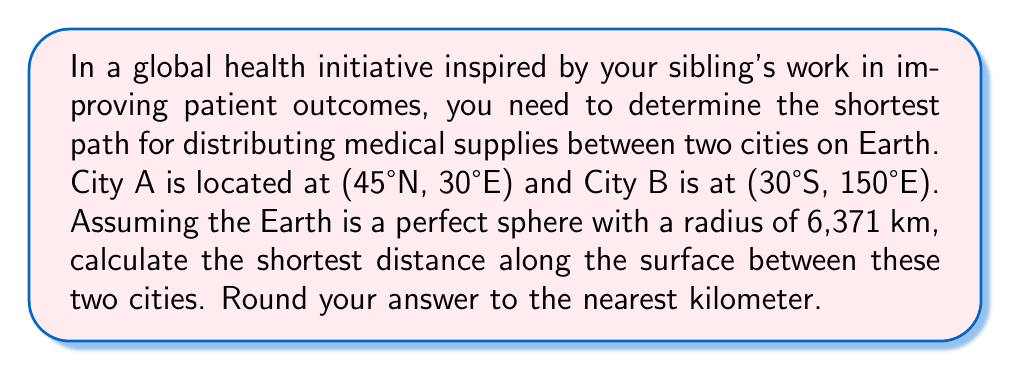Can you solve this math problem? To solve this problem, we need to use the great circle distance formula, which gives the shortest path between two points on a spherical surface. This is crucial for optimal healthcare resource allocation on a global scale.

Step 1: Convert the given coordinates to radians.
City A: $\phi_1 = 45° \cdot \frac{\pi}{180} = 0.7854$ rad, $\lambda_1 = 30° \cdot \frac{\pi}{180} = 0.5236$ rad
City B: $\phi_2 = -30° \cdot \frac{\pi}{180} = -0.5236$ rad, $\lambda_2 = 150° \cdot \frac{\pi}{180} = 2.6180$ rad

Step 2: Calculate the central angle $\Delta\sigma$ using the great circle distance formula:
$$\Delta\sigma = \arccos(\sin\phi_1 \sin\phi_2 + \cos\phi_1 \cos\phi_2 \cos(\lambda_2 - \lambda_1))$$

Step 3: Substitute the values:
$$\Delta\sigma = \arccos(\sin(0.7854) \sin(-0.5236) + \cos(0.7854) \cos(-0.5236) \cos(2.6180 - 0.5236))$$

Step 4: Calculate the result:
$$\Delta\sigma = 1.9635 \text{ radians}$$

Step 5: Calculate the distance $d$ along the Earth's surface:
$$d = R \cdot \Delta\sigma$$
where $R$ is the Earth's radius (6,371 km)

$$d = 6,371 \cdot 1.9635 = 12,509.45 \text{ km}$$

Step 6: Round to the nearest kilometer:
$$d \approx 12,509 \text{ km}$$

This distance represents the optimal path for distributing medical supplies between the two cities, ensuring efficient resource allocation in the global health initiative.
Answer: 12,509 km 